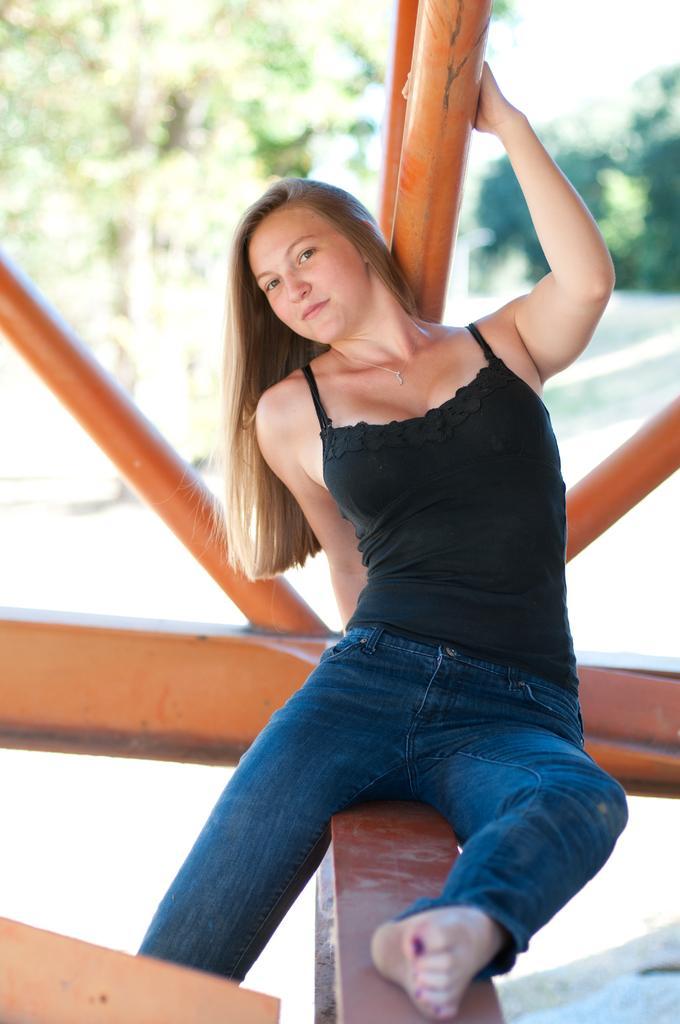Please provide a concise description of this image. In this image we can see a woman is sitting on a wooden platform. In the background we can see poles, road, and trees. 